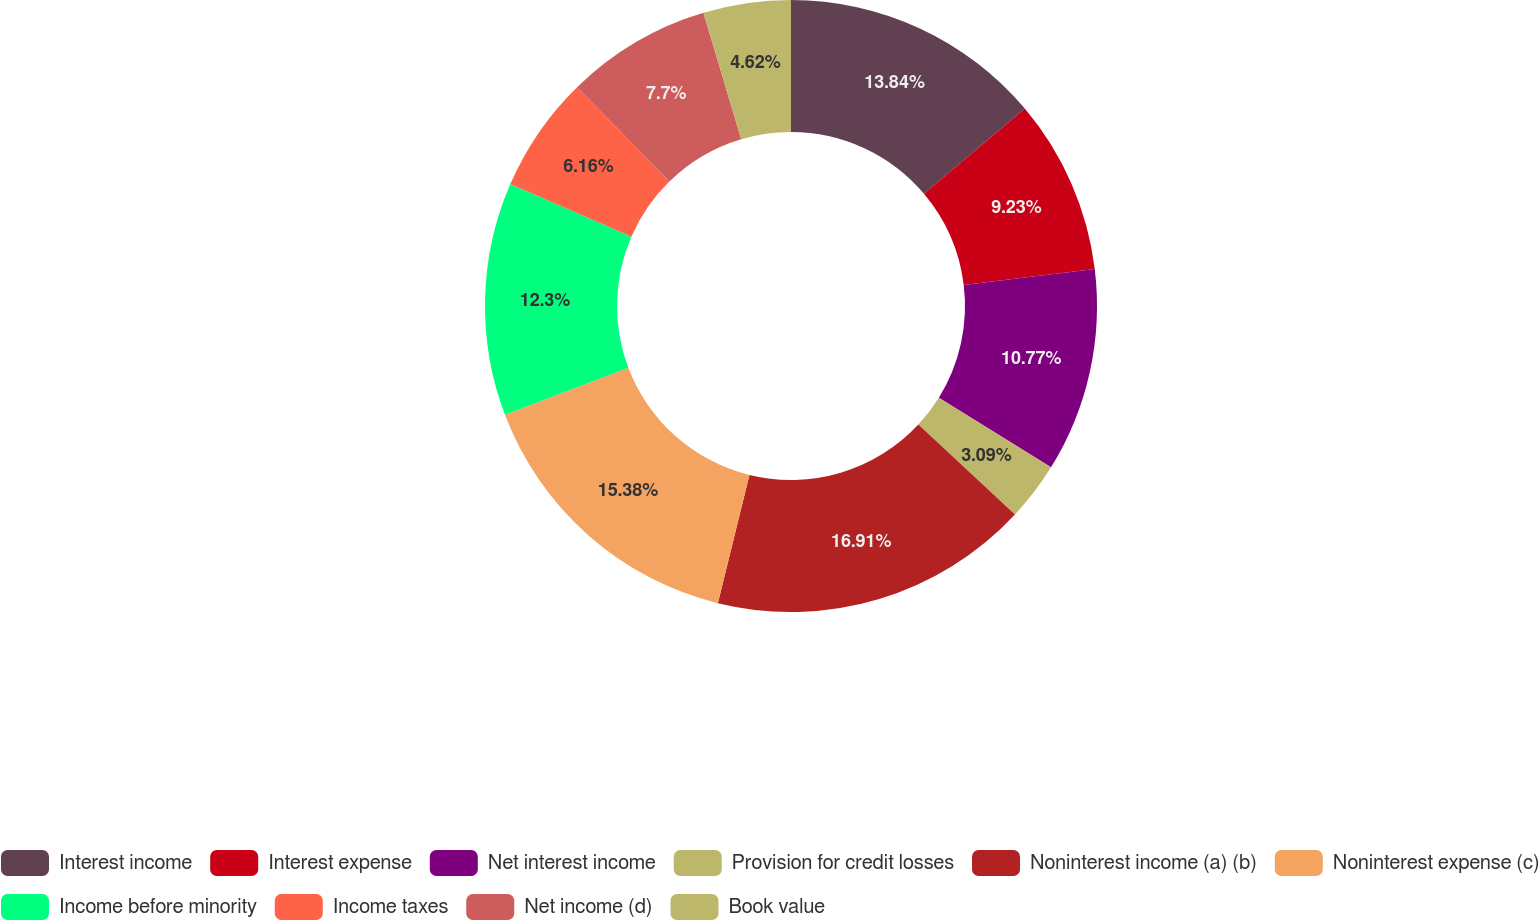Convert chart. <chart><loc_0><loc_0><loc_500><loc_500><pie_chart><fcel>Interest income<fcel>Interest expense<fcel>Net interest income<fcel>Provision for credit losses<fcel>Noninterest income (a) (b)<fcel>Noninterest expense (c)<fcel>Income before minority<fcel>Income taxes<fcel>Net income (d)<fcel>Book value<nl><fcel>13.84%<fcel>9.23%<fcel>10.77%<fcel>3.09%<fcel>16.91%<fcel>15.38%<fcel>12.3%<fcel>6.16%<fcel>7.7%<fcel>4.62%<nl></chart> 